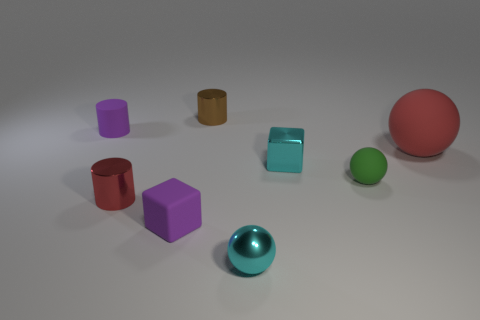Is there a green object that has the same size as the red metallic cylinder?
Provide a succinct answer. Yes. There is a tiny purple matte thing in front of the green matte sphere; is it the same shape as the green matte object?
Keep it short and to the point. No. There is a small purple object that is in front of the rubber cylinder; what material is it?
Give a very brief answer. Rubber. What shape is the small purple matte thing to the left of the small metal cylinder that is in front of the brown cylinder?
Give a very brief answer. Cylinder. There is a small brown object; does it have the same shape as the small purple matte object that is in front of the large rubber thing?
Your answer should be very brief. No. What number of tiny green things are in front of the tiny purple matte object that is right of the red metallic cylinder?
Give a very brief answer. 0. There is a small cyan thing that is the same shape as the big red object; what is it made of?
Your answer should be very brief. Metal. How many cyan objects are cylinders or big balls?
Your answer should be compact. 0. Is there any other thing of the same color as the metal cube?
Offer a very short reply. Yes. The cylinder that is in front of the matte object that is right of the tiny green thing is what color?
Your answer should be compact. Red. 